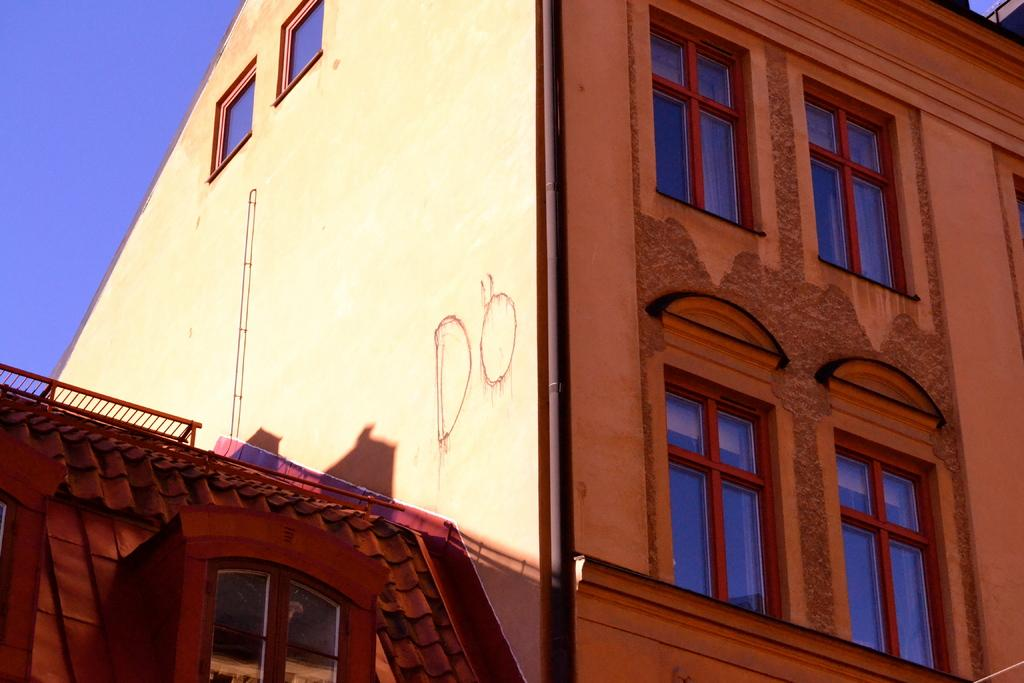What is the main structure in the picture? There is a building in the picture. What features can be observed on the building? The building has windows and a pipe. What type of stone is used to construct the collar on the building in the image? There is no collar present on the building in the image. 